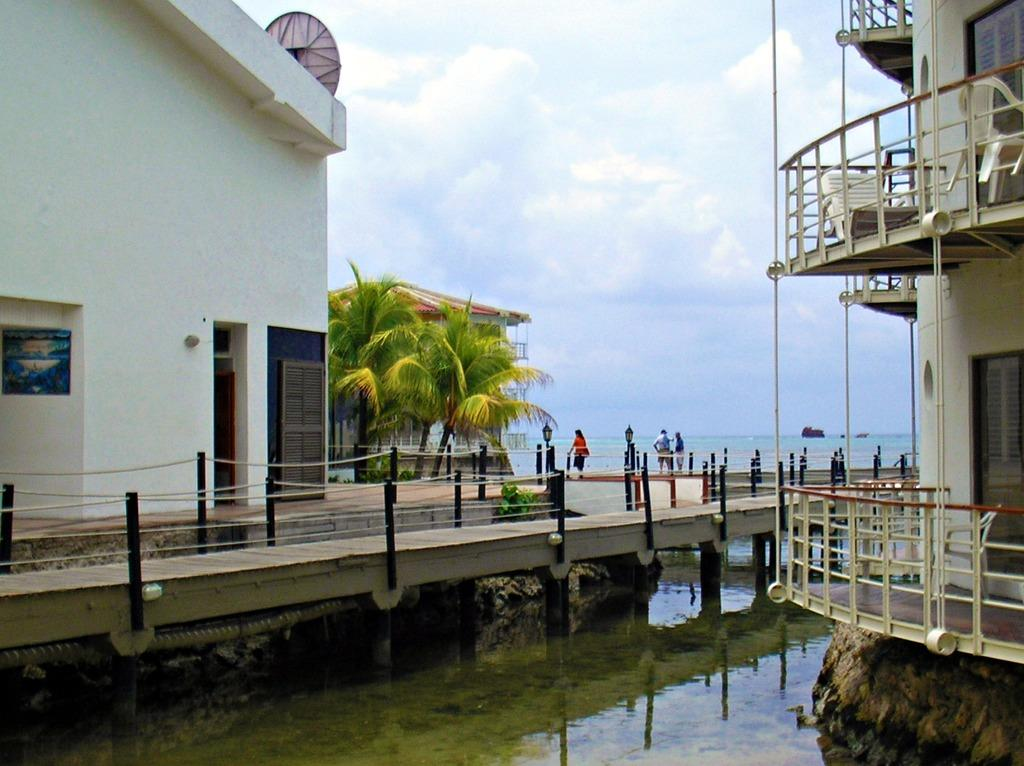What type of structures are located on the water in the image? There are houses on the water in the image. What are the people in the image doing? The people in the image are walking on the pavement. What can be seen in front of the people in the image? There are trees in front of the people in the image. What is visible in the background of the image? There is water visible in the background of the image. What type of music can be heard playing in the background of the image? There is no music present in the image, as it only shows houses on the water, people walking, trees, and water in the background. Can you see a girl in the image? There is no girl mentioned or visible in the image based on the provided facts. 